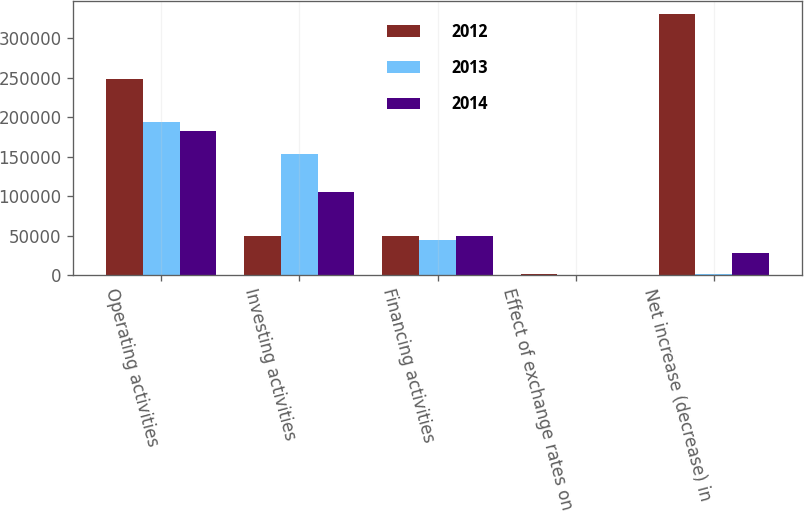Convert chart. <chart><loc_0><loc_0><loc_500><loc_500><stacked_bar_chart><ecel><fcel>Operating activities<fcel>Investing activities<fcel>Financing activities<fcel>Effect of exchange rates on<fcel>Net increase (decrease) in<nl><fcel>2012<fcel>248325<fcel>49434<fcel>49434<fcel>1900<fcel>331123<nl><fcel>2013<fcel>194766<fcel>153149<fcel>44173<fcel>643<fcel>1913<nl><fcel>2014<fcel>183331<fcel>105535<fcel>49434<fcel>40<fcel>28322<nl></chart> 